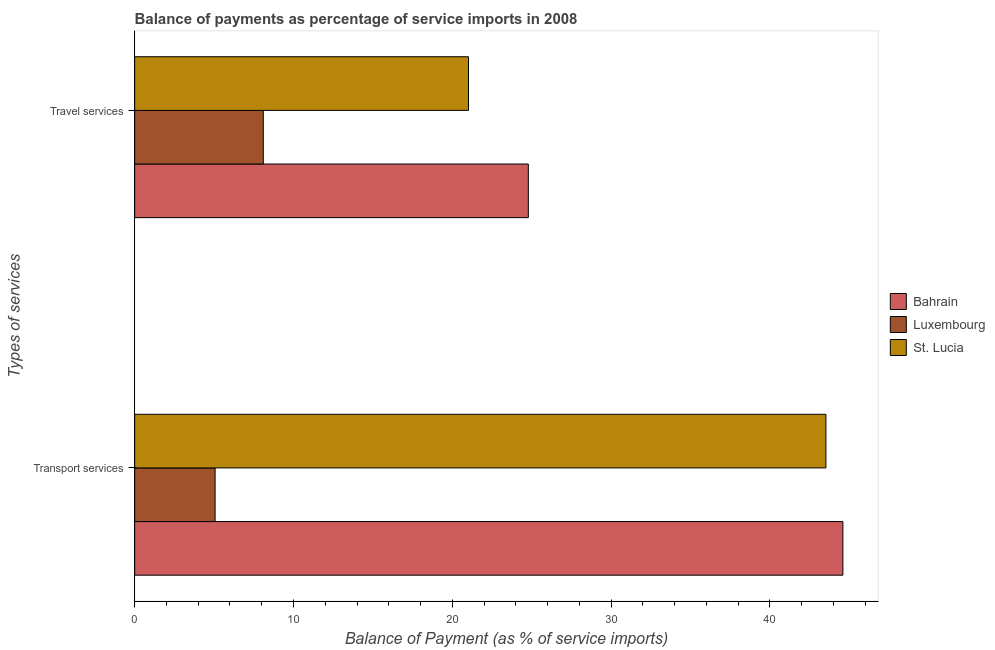Are the number of bars per tick equal to the number of legend labels?
Provide a short and direct response. Yes. Are the number of bars on each tick of the Y-axis equal?
Make the answer very short. Yes. What is the label of the 1st group of bars from the top?
Your answer should be compact. Travel services. What is the balance of payments of travel services in Luxembourg?
Ensure brevity in your answer.  8.1. Across all countries, what is the maximum balance of payments of travel services?
Your response must be concise. 24.79. Across all countries, what is the minimum balance of payments of travel services?
Make the answer very short. 8.1. In which country was the balance of payments of travel services maximum?
Ensure brevity in your answer.  Bahrain. In which country was the balance of payments of transport services minimum?
Make the answer very short. Luxembourg. What is the total balance of payments of transport services in the graph?
Provide a succinct answer. 93.18. What is the difference between the balance of payments of travel services in St. Lucia and that in Bahrain?
Your answer should be very brief. -3.77. What is the difference between the balance of payments of transport services in Luxembourg and the balance of payments of travel services in Bahrain?
Give a very brief answer. -19.72. What is the average balance of payments of transport services per country?
Give a very brief answer. 31.06. What is the difference between the balance of payments of transport services and balance of payments of travel services in Bahrain?
Provide a short and direct response. 19.81. What is the ratio of the balance of payments of transport services in St. Lucia to that in Luxembourg?
Offer a terse response. 8.59. Is the balance of payments of transport services in St. Lucia less than that in Bahrain?
Your answer should be very brief. Yes. What does the 3rd bar from the top in Travel services represents?
Your answer should be compact. Bahrain. What does the 3rd bar from the bottom in Transport services represents?
Provide a succinct answer. St. Lucia. How many countries are there in the graph?
Offer a terse response. 3. How many legend labels are there?
Make the answer very short. 3. How are the legend labels stacked?
Give a very brief answer. Vertical. What is the title of the graph?
Provide a short and direct response. Balance of payments as percentage of service imports in 2008. What is the label or title of the X-axis?
Your answer should be very brief. Balance of Payment (as % of service imports). What is the label or title of the Y-axis?
Ensure brevity in your answer.  Types of services. What is the Balance of Payment (as % of service imports) in Bahrain in Transport services?
Provide a succinct answer. 44.59. What is the Balance of Payment (as % of service imports) in Luxembourg in Transport services?
Provide a succinct answer. 5.07. What is the Balance of Payment (as % of service imports) of St. Lucia in Transport services?
Keep it short and to the point. 43.52. What is the Balance of Payment (as % of service imports) of Bahrain in Travel services?
Your response must be concise. 24.79. What is the Balance of Payment (as % of service imports) in Luxembourg in Travel services?
Provide a succinct answer. 8.1. What is the Balance of Payment (as % of service imports) in St. Lucia in Travel services?
Provide a succinct answer. 21.02. Across all Types of services, what is the maximum Balance of Payment (as % of service imports) of Bahrain?
Give a very brief answer. 44.59. Across all Types of services, what is the maximum Balance of Payment (as % of service imports) of Luxembourg?
Your answer should be very brief. 8.1. Across all Types of services, what is the maximum Balance of Payment (as % of service imports) in St. Lucia?
Ensure brevity in your answer.  43.52. Across all Types of services, what is the minimum Balance of Payment (as % of service imports) in Bahrain?
Offer a very short reply. 24.79. Across all Types of services, what is the minimum Balance of Payment (as % of service imports) of Luxembourg?
Your answer should be compact. 5.07. Across all Types of services, what is the minimum Balance of Payment (as % of service imports) of St. Lucia?
Ensure brevity in your answer.  21.02. What is the total Balance of Payment (as % of service imports) of Bahrain in the graph?
Provide a short and direct response. 69.38. What is the total Balance of Payment (as % of service imports) of Luxembourg in the graph?
Your response must be concise. 13.16. What is the total Balance of Payment (as % of service imports) of St. Lucia in the graph?
Your answer should be very brief. 64.54. What is the difference between the Balance of Payment (as % of service imports) in Bahrain in Transport services and that in Travel services?
Keep it short and to the point. 19.81. What is the difference between the Balance of Payment (as % of service imports) in Luxembourg in Transport services and that in Travel services?
Provide a succinct answer. -3.03. What is the difference between the Balance of Payment (as % of service imports) of St. Lucia in Transport services and that in Travel services?
Provide a short and direct response. 22.5. What is the difference between the Balance of Payment (as % of service imports) in Bahrain in Transport services and the Balance of Payment (as % of service imports) in Luxembourg in Travel services?
Provide a succinct answer. 36.49. What is the difference between the Balance of Payment (as % of service imports) in Bahrain in Transport services and the Balance of Payment (as % of service imports) in St. Lucia in Travel services?
Your answer should be compact. 23.57. What is the difference between the Balance of Payment (as % of service imports) in Luxembourg in Transport services and the Balance of Payment (as % of service imports) in St. Lucia in Travel services?
Offer a very short reply. -15.96. What is the average Balance of Payment (as % of service imports) in Bahrain per Types of services?
Your answer should be very brief. 34.69. What is the average Balance of Payment (as % of service imports) in Luxembourg per Types of services?
Keep it short and to the point. 6.58. What is the average Balance of Payment (as % of service imports) in St. Lucia per Types of services?
Offer a very short reply. 32.27. What is the difference between the Balance of Payment (as % of service imports) in Bahrain and Balance of Payment (as % of service imports) in Luxembourg in Transport services?
Provide a succinct answer. 39.53. What is the difference between the Balance of Payment (as % of service imports) of Bahrain and Balance of Payment (as % of service imports) of St. Lucia in Transport services?
Keep it short and to the point. 1.07. What is the difference between the Balance of Payment (as % of service imports) of Luxembourg and Balance of Payment (as % of service imports) of St. Lucia in Transport services?
Your answer should be compact. -38.46. What is the difference between the Balance of Payment (as % of service imports) in Bahrain and Balance of Payment (as % of service imports) in Luxembourg in Travel services?
Ensure brevity in your answer.  16.69. What is the difference between the Balance of Payment (as % of service imports) in Bahrain and Balance of Payment (as % of service imports) in St. Lucia in Travel services?
Offer a terse response. 3.77. What is the difference between the Balance of Payment (as % of service imports) of Luxembourg and Balance of Payment (as % of service imports) of St. Lucia in Travel services?
Give a very brief answer. -12.92. What is the ratio of the Balance of Payment (as % of service imports) in Bahrain in Transport services to that in Travel services?
Provide a short and direct response. 1.8. What is the ratio of the Balance of Payment (as % of service imports) in Luxembourg in Transport services to that in Travel services?
Offer a terse response. 0.63. What is the ratio of the Balance of Payment (as % of service imports) in St. Lucia in Transport services to that in Travel services?
Provide a short and direct response. 2.07. What is the difference between the highest and the second highest Balance of Payment (as % of service imports) in Bahrain?
Your answer should be very brief. 19.81. What is the difference between the highest and the second highest Balance of Payment (as % of service imports) of Luxembourg?
Provide a short and direct response. 3.03. What is the difference between the highest and the second highest Balance of Payment (as % of service imports) of St. Lucia?
Keep it short and to the point. 22.5. What is the difference between the highest and the lowest Balance of Payment (as % of service imports) of Bahrain?
Provide a succinct answer. 19.81. What is the difference between the highest and the lowest Balance of Payment (as % of service imports) of Luxembourg?
Ensure brevity in your answer.  3.03. What is the difference between the highest and the lowest Balance of Payment (as % of service imports) of St. Lucia?
Ensure brevity in your answer.  22.5. 